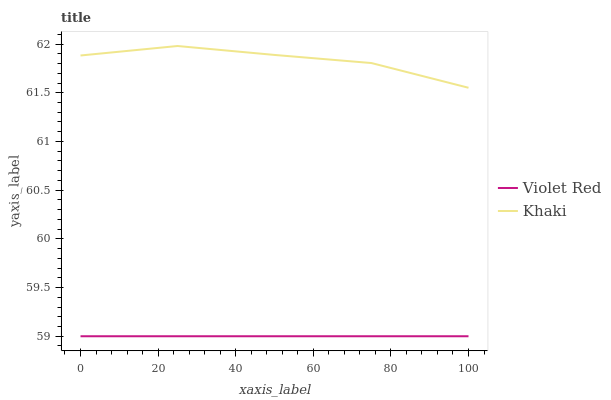Does Violet Red have the minimum area under the curve?
Answer yes or no. Yes. Does Khaki have the maximum area under the curve?
Answer yes or no. Yes. Does Khaki have the minimum area under the curve?
Answer yes or no. No. Is Violet Red the smoothest?
Answer yes or no. Yes. Is Khaki the roughest?
Answer yes or no. Yes. Is Khaki the smoothest?
Answer yes or no. No. Does Violet Red have the lowest value?
Answer yes or no. Yes. Does Khaki have the lowest value?
Answer yes or no. No. Does Khaki have the highest value?
Answer yes or no. Yes. Is Violet Red less than Khaki?
Answer yes or no. Yes. Is Khaki greater than Violet Red?
Answer yes or no. Yes. Does Violet Red intersect Khaki?
Answer yes or no. No. 